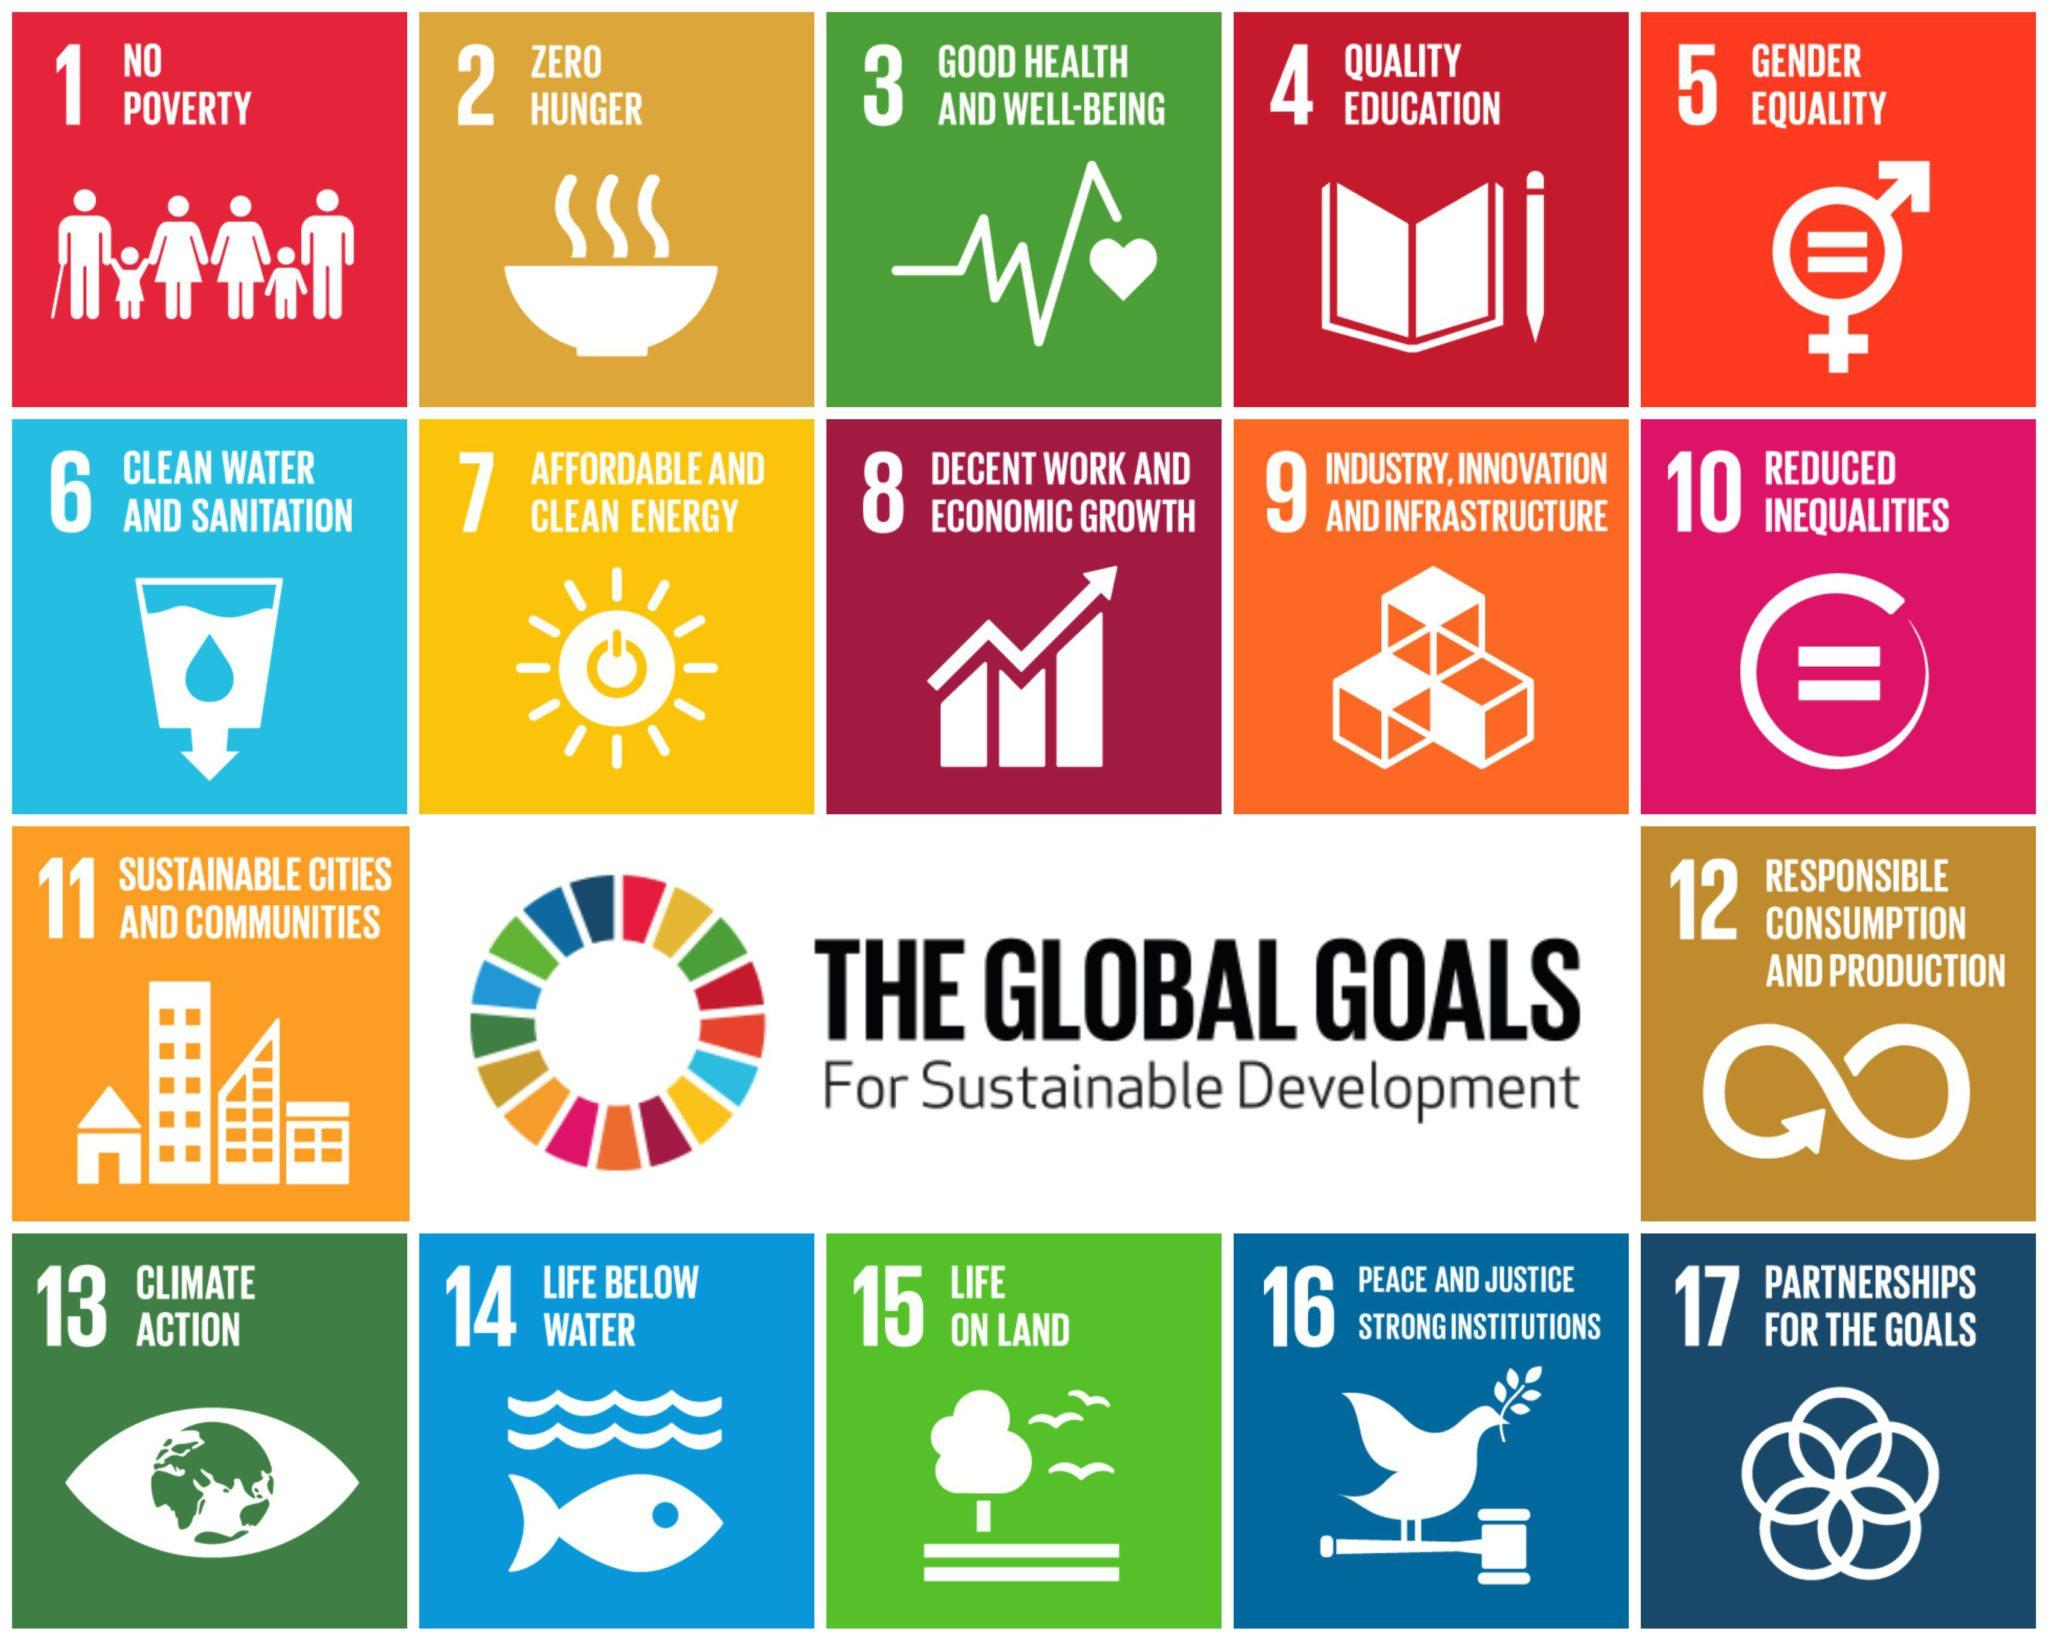Mention a couple of crucial points in this snapshot. The goal of sustainable development is to define what it is for. Zero hunger is demonstrated by the symbol of a bowl or a book. How many goals are shown in the last row? There are 5 goals in total. The goals outlined in the third row include sustainable cities and communities and responsible consumption and production. The fish and water symbol denotes the goal of promoting life below water. 